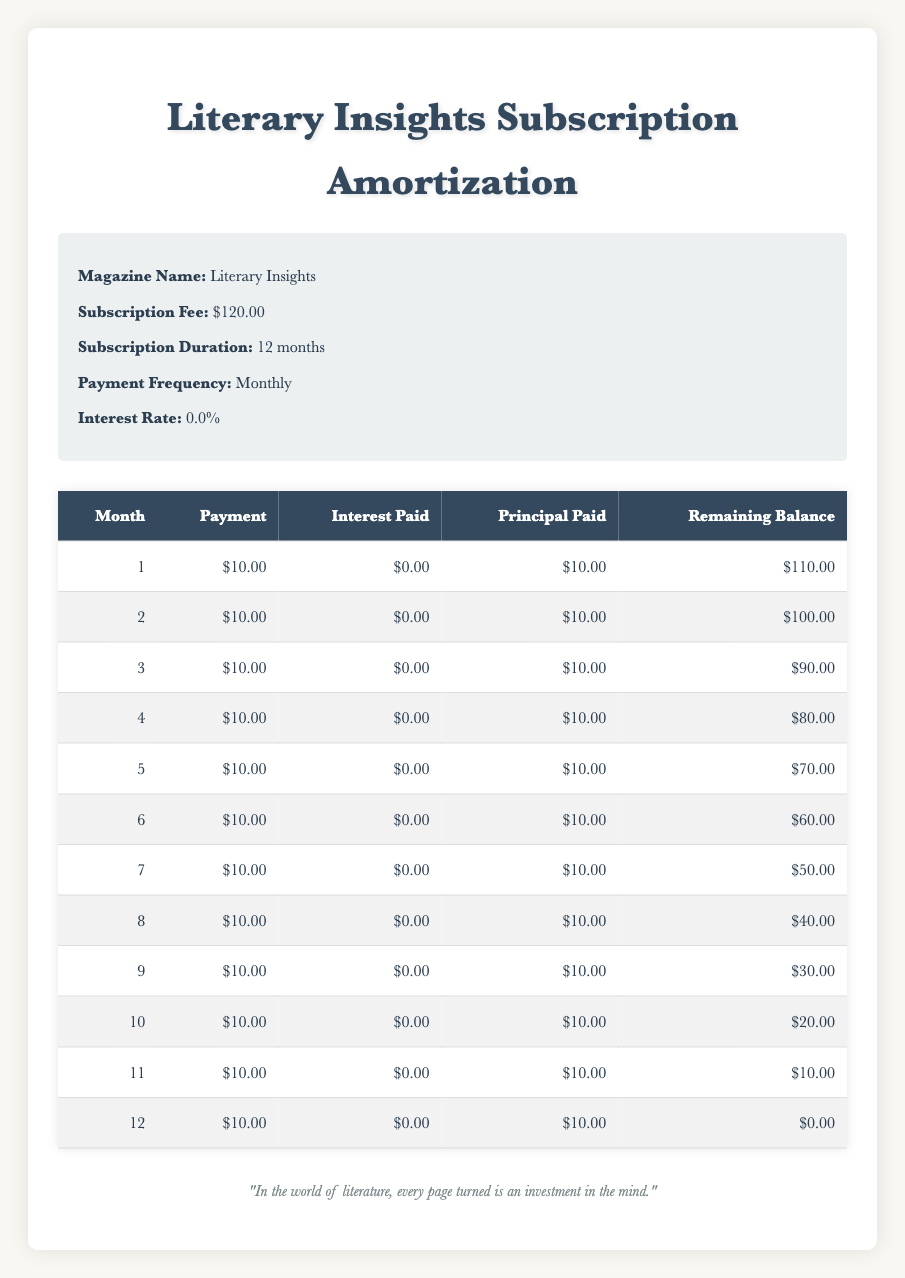What is the total amount paid over the 12 months? Each monthly payment is $10.00. Over 12 months, the total payment is calculated by multiplying the monthly payment by the number of months: 10.00 x 12 = 120.00.
Answer: 120.00 How much is the remaining balance after the 6th month? Referring to the amortization schedule, the remaining balance after the 6th month is shown in the table as $60.00.
Answer: 60.00 What is the average amount paid in principal each month? The total principal paid over the 12 months is $10.00 multiplied by 12, equaling $120.00. To find the average, we divide the total principal by the number of months: 120.00 / 12 = 10.00.
Answer: 10.00 Is there any interest paid during the subscription? The interest paid for each month is listed as $0.00 in the table. Since all entries indicate no interest paid, the answer is affirmative.
Answer: Yes What was the principal paid in the first 6 months? To find the total principal paid in the first 6 months, we sum the principal paid each month from 1 to 6: 10.00 + 10.00 + 10.00 + 10.00 + 10.00 + 10.00 = 60.00.
Answer: 60.00 What is the remaining balance before the last payment? Looking at the table, the remaining balance after the 11th month is $10.00; that is the amount due before making the last payment.
Answer: 10.00 How many months does it take to completely pay off the subscription? The table shows that the remaining balance goes to $0.00 after the 12th month, indicating that it takes a total of 12 months to pay off the subscription.
Answer: 12 What was the principal paid in the 8th month? In the 8th month, the principal paid is specifically provided in the table as $10.00.
Answer: 10.00 What is the total amount of interest paid over the subscription duration? The table consistently shows that $0.00 was paid in interest each month. Adding these up gives: 0.00 + 0.00 + ... + 0.00 = 0.00.
Answer: 0.00 